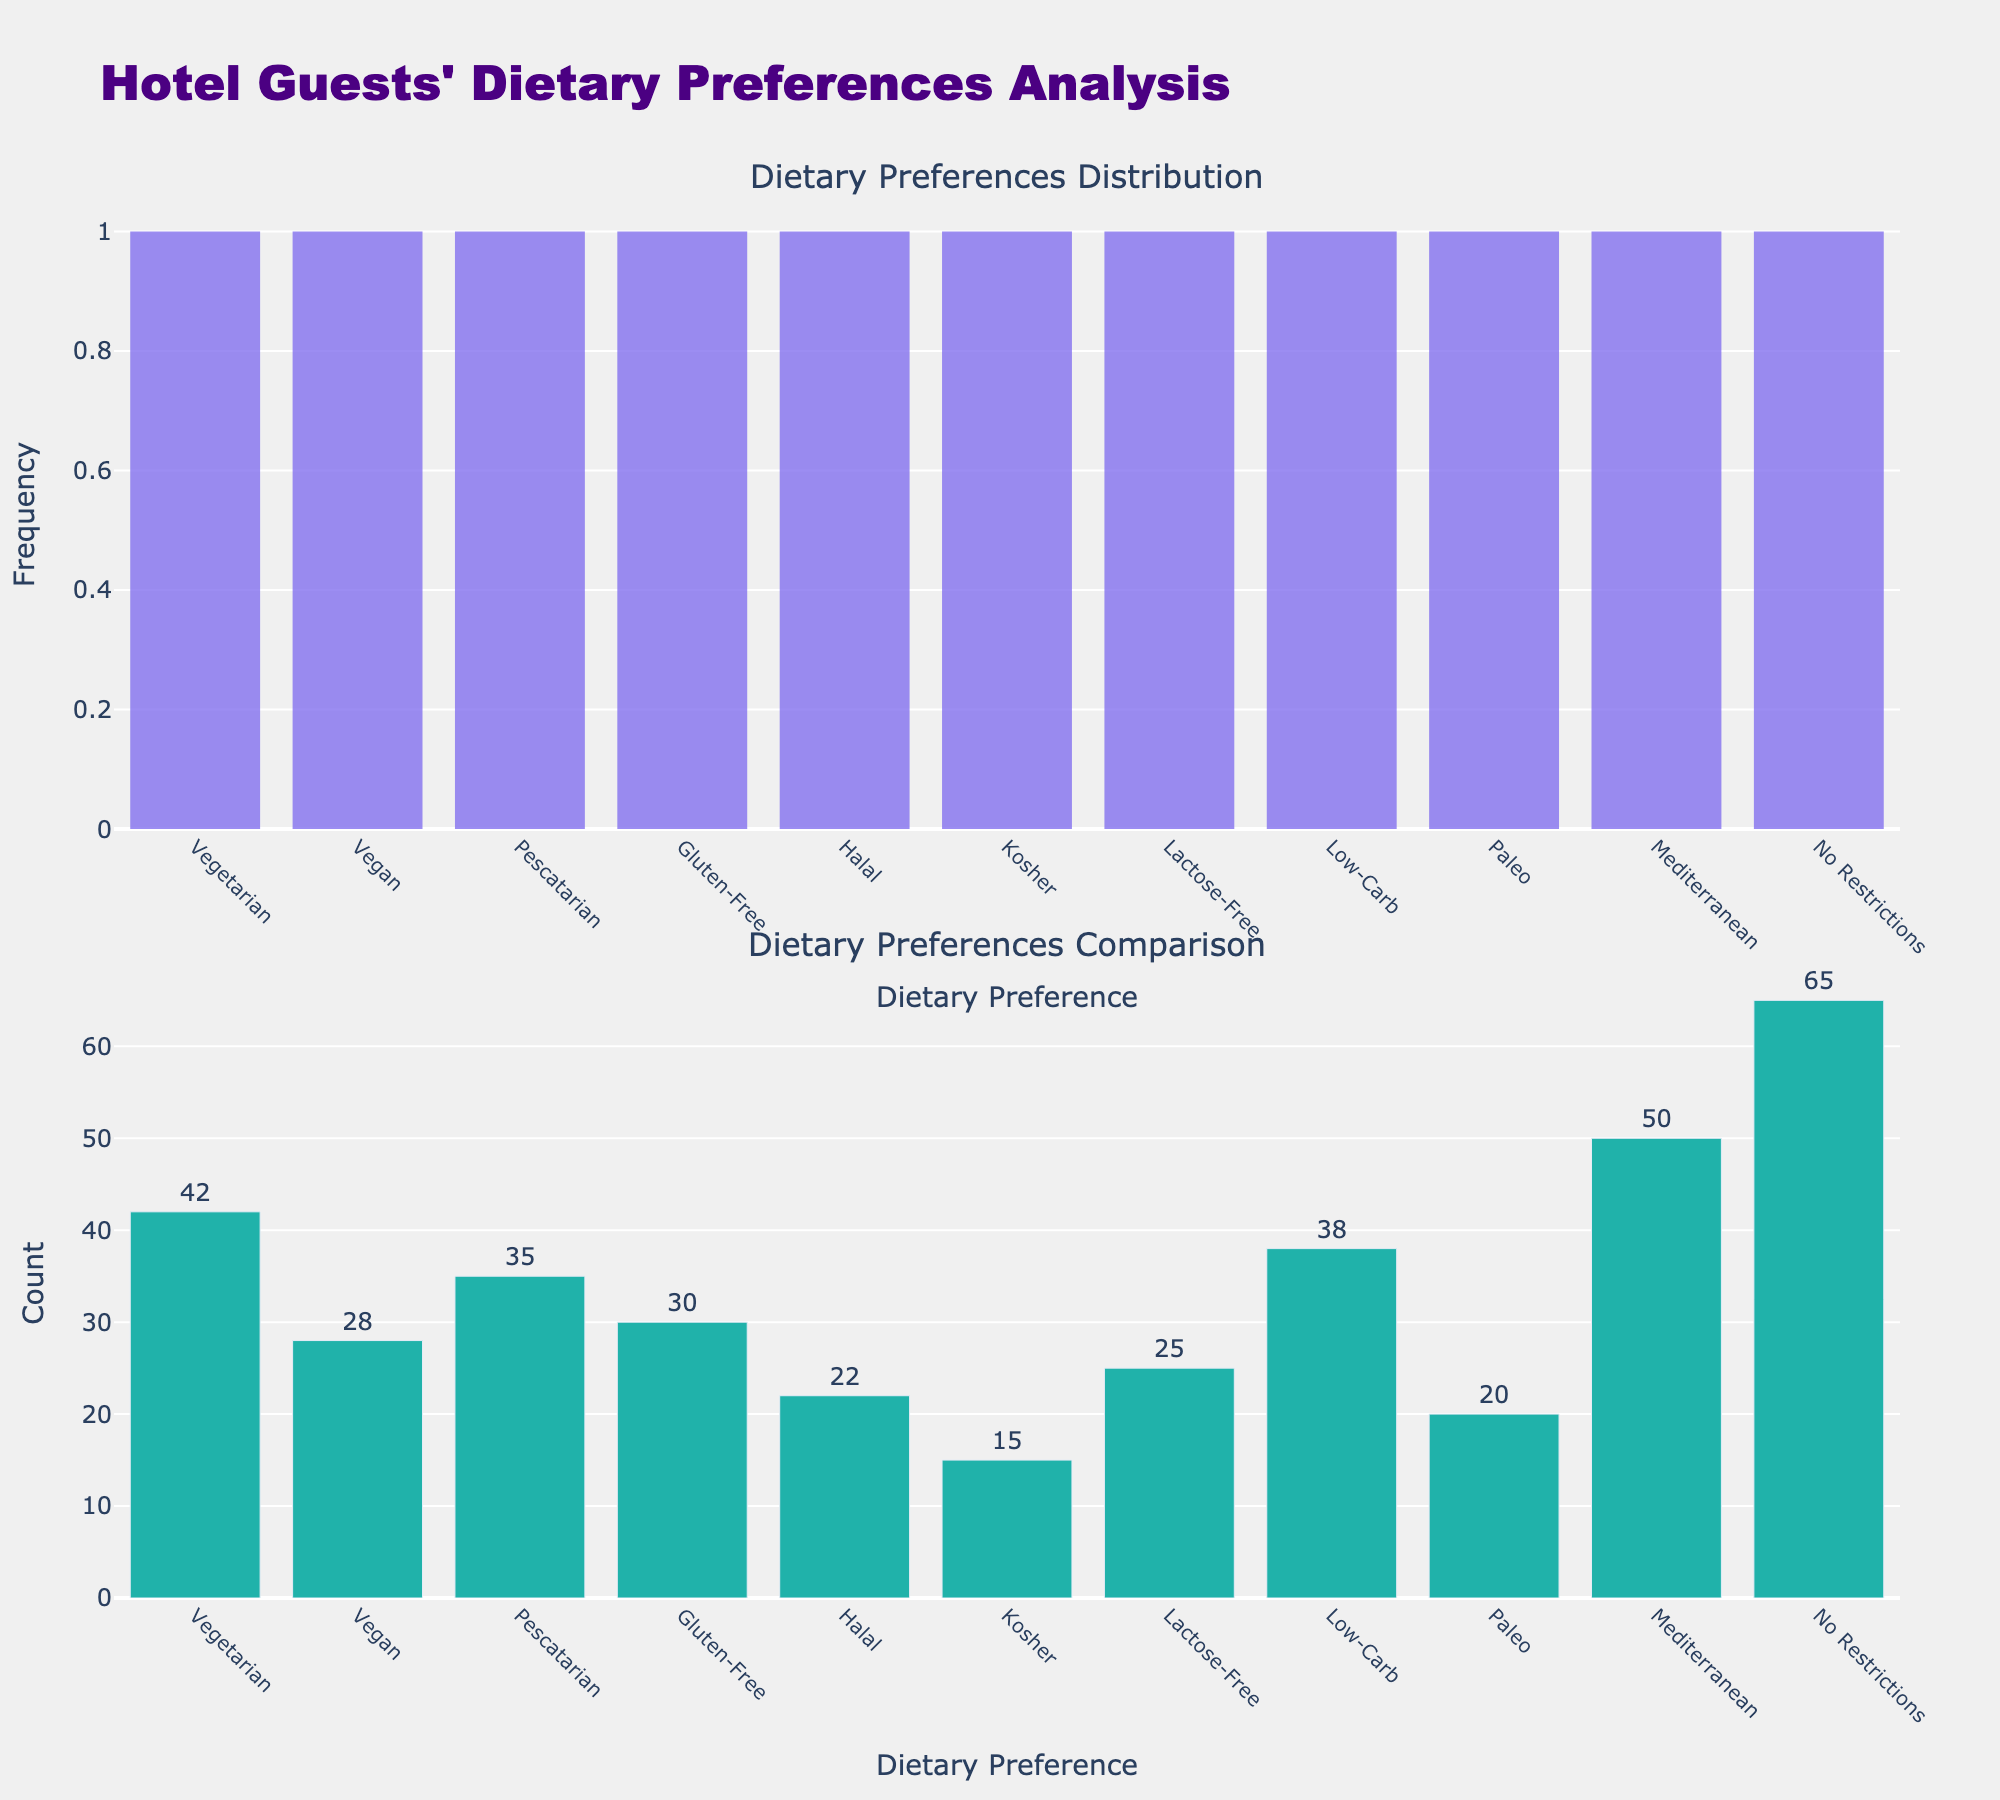What is the title of the figure? The title is located at the top center of the figure and reads "Hotel Guests' Dietary Preferences Analysis".
Answer: Hotel Guests' Dietary Preferences Analysis What is the most common dietary preference among hotel guests? In both the histogram and bar chart, the "No Restrictions" bar is the tallest, indicating it has the highest frequency.
Answer: No Restrictions How many guests prefer a Paleo diet? Refer to the label of the "Paleo" bar in the bar chart, which has a count of 20.
Answer: 20 What are the dietary preferences with fewer than 25 guests? Look at the bars with counts less than 25 in the bar chart: Halal (22), Paleo (20), and Kosher (15).
Answer: Halal, Paleo, Kosher Which dietary preference has a count closest to the median count of all preferences? List all counts: [42, 28, 35, 30, 22, 15, 25, 38, 20, 50, 65]. The median is the middle value of the sorted list: 28 (Vegan) and 30 (Gluten-Free). The preference closest to these values is Gluten-Free.
Answer: Gluten-Free Compare the frequency of Halal and Kosher dietary preferences. Which is higher? In both the histogram and bar chart, the Halal bar (22) is higher than the Kosher bar (15).
Answer: Halal What is the difference in count between the Mediterranean and No Restrictions preferences? The count for Mediterranean is 50, and for No Restrictions, it is 65. The difference is 65 - 50 = 15.
Answer: 15 Identify the dietary preference that has approximately one-third of the count of the No Restrictions preference. One-third of the No Restrictions count (65) is approximately 21.67. The dietary preference closest to this value is Paleo (20).
Answer: Paleo Which preference has the least frequency among hotel guests? In the bar chart, the Kosher bar is the shortest, indicating it has the least frequency of 15.
Answer: Kosher What is the total count of guests with either Vegetarian or Vegan dietary preferences? Sum the counts: Vegetarian (42) and Vegan (28), which gives 42 + 28 = 70.
Answer: 70 